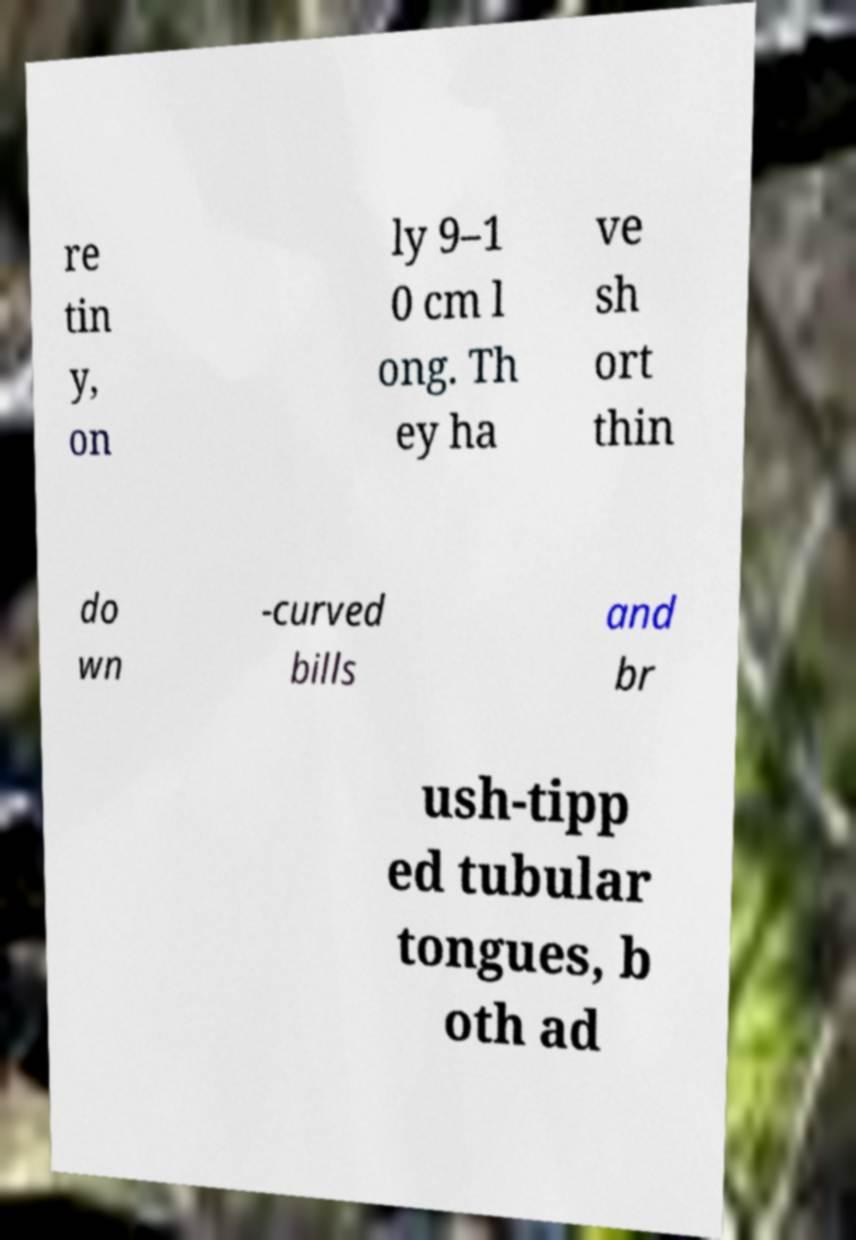There's text embedded in this image that I need extracted. Can you transcribe it verbatim? re tin y, on ly 9–1 0 cm l ong. Th ey ha ve sh ort thin do wn -curved bills and br ush-tipp ed tubular tongues, b oth ad 